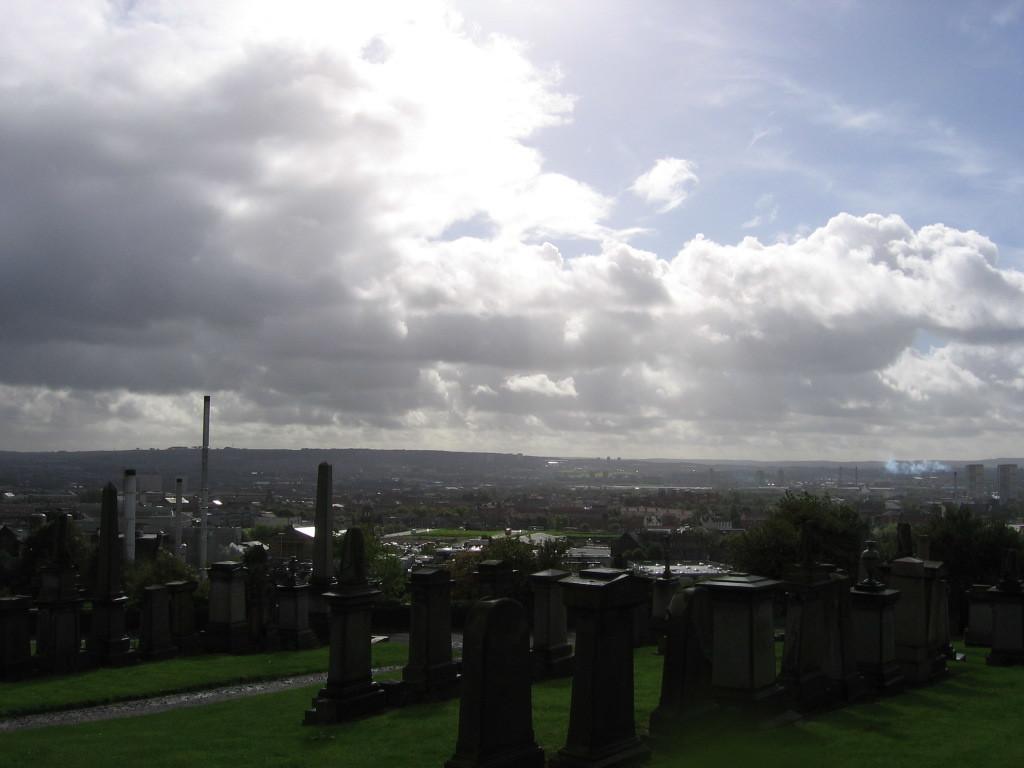Could you give a brief overview of what you see in this image? In this image, we can see trees, pillars, buildings and towers and we can see poles. At the bottom, there is ground and at the top, there is sky. 